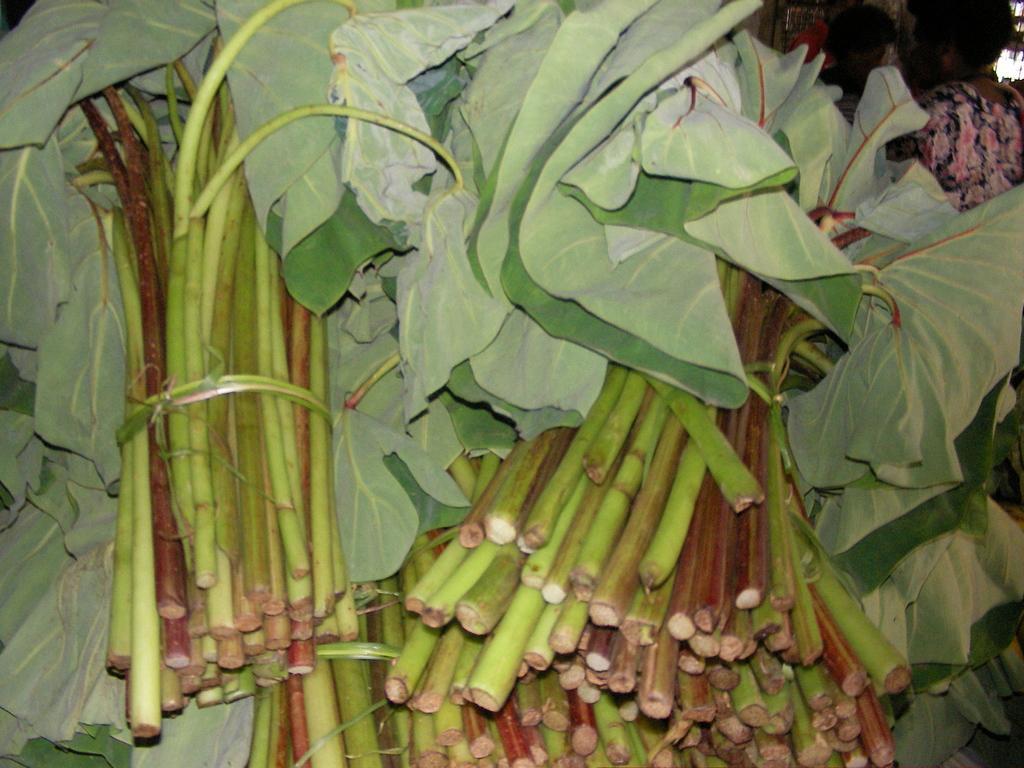Can you describe this image briefly? In this image there are few bunches of leaves. Right top there are few persons. 